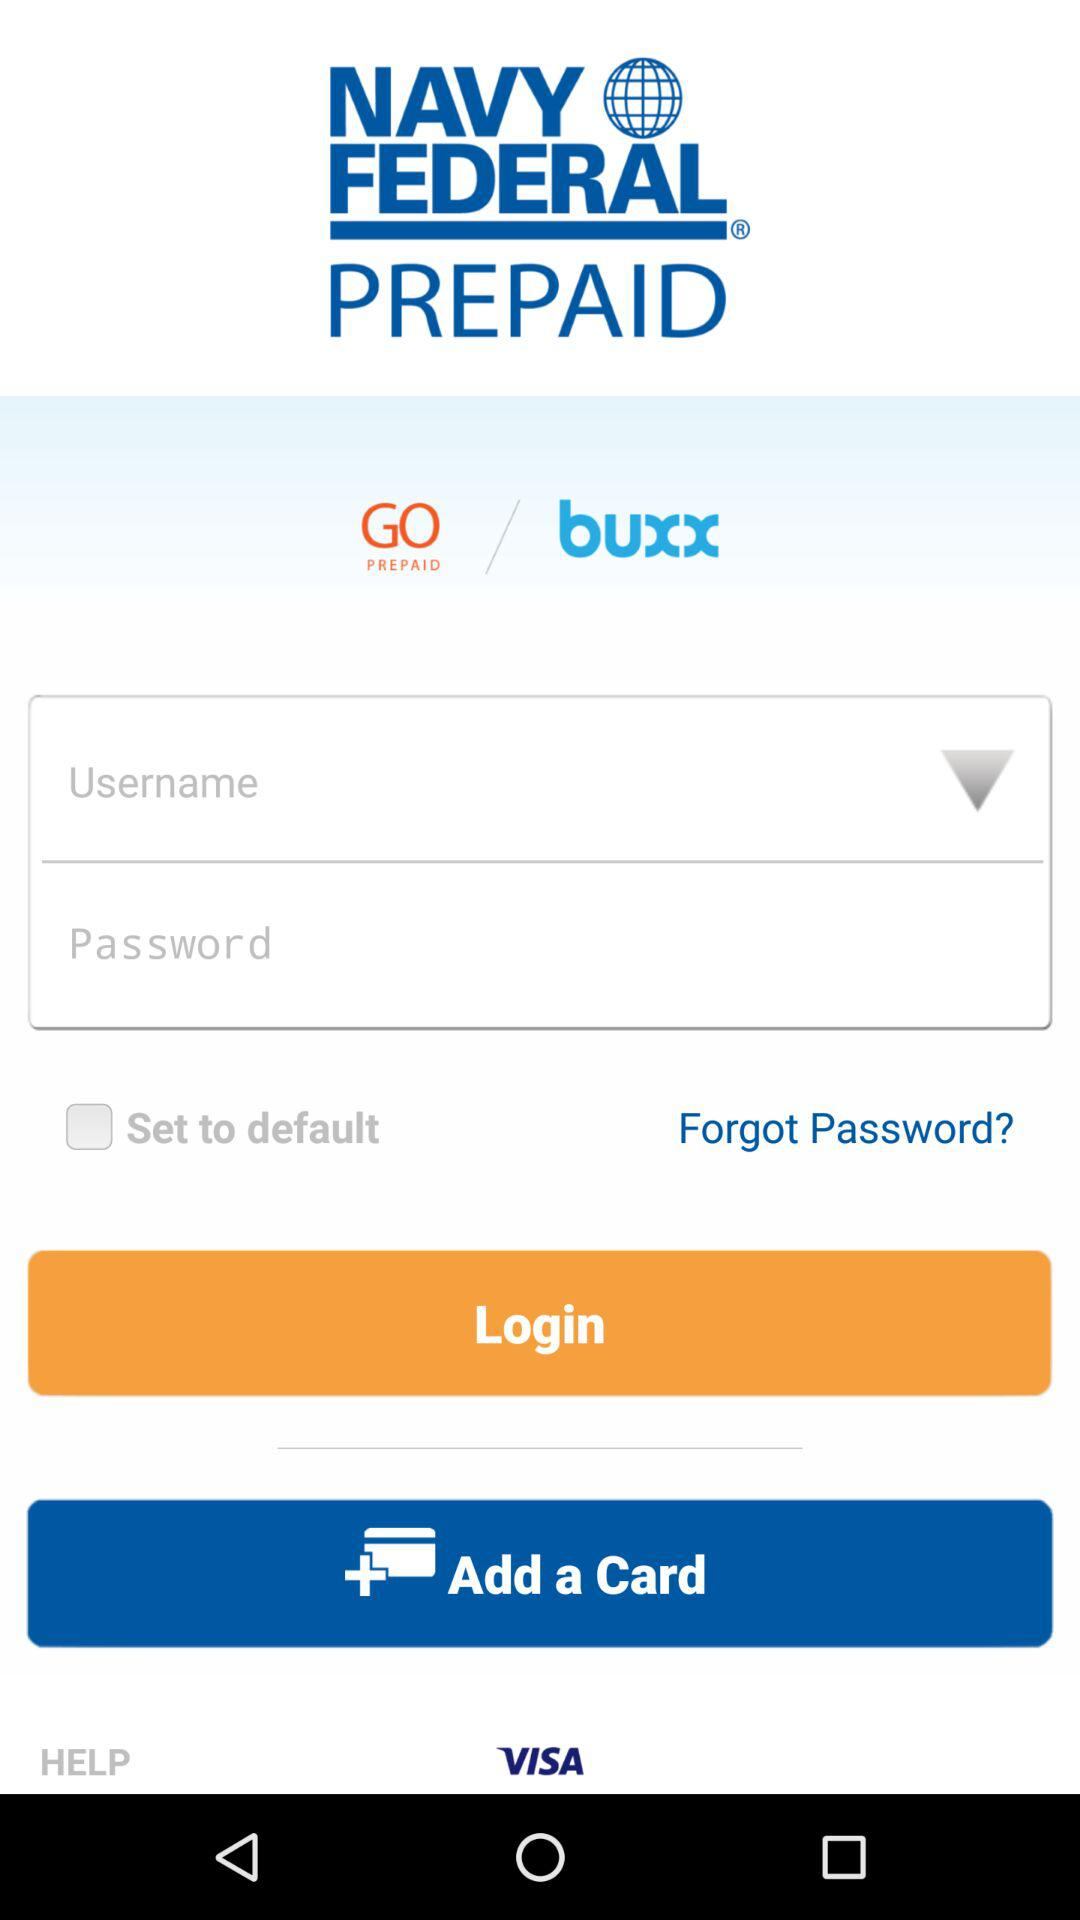What is the status of "Set to default"? The status is "off". 